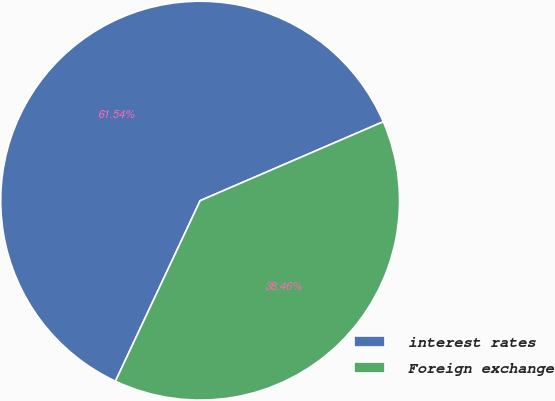Convert chart. <chart><loc_0><loc_0><loc_500><loc_500><pie_chart><fcel>interest rates<fcel>Foreign exchange<nl><fcel>61.54%<fcel>38.46%<nl></chart> 